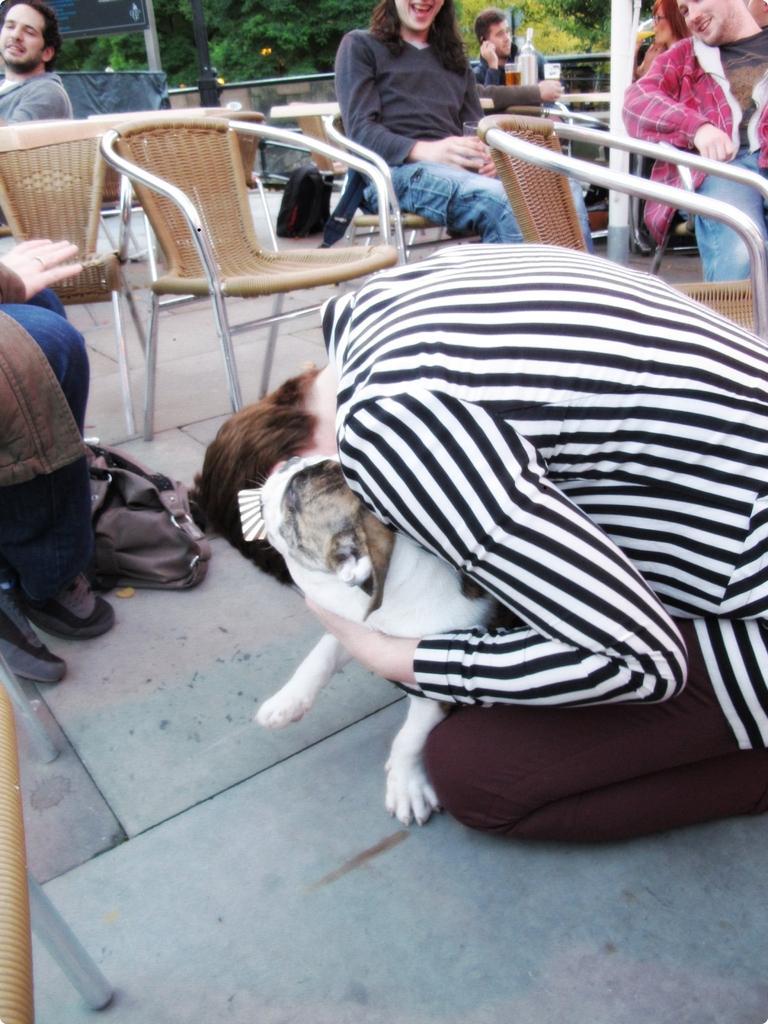How would you summarize this image in a sentence or two? In this image i can see a group of people are sitting on a chair and a woman is sitting on the ground and holding a dog. 